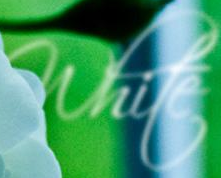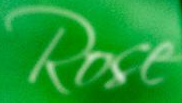What text appears in these images from left to right, separated by a semicolon? white; Rose 